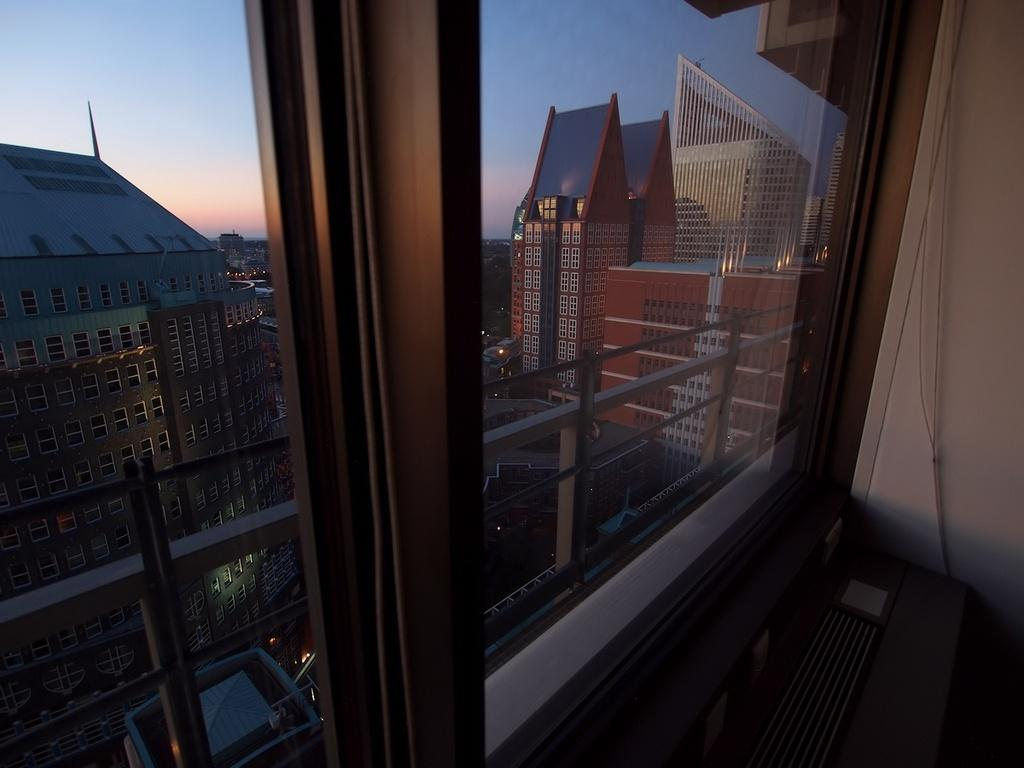What is the main feature of the image? There is a glass window in the image. What can be seen through the window? Buildings and vehicles are visible on the other side of the window. What type of locket is hanging from the window in the image? There is no locket present in the image; it only features a glass window with buildings and vehicles visible on the other side. 